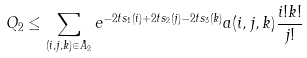<formula> <loc_0><loc_0><loc_500><loc_500>Q _ { 2 } \leq \sum _ { ( i , j , k ) \in A _ { 2 } } e ^ { - 2 t s _ { 1 } ( i ) + 2 t s _ { 2 } ( j ) - 2 t s _ { 3 } ( k ) } a ( i , j , k ) \frac { i ! k ! } { j ! }</formula> 